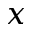<formula> <loc_0><loc_0><loc_500><loc_500>x</formula> 